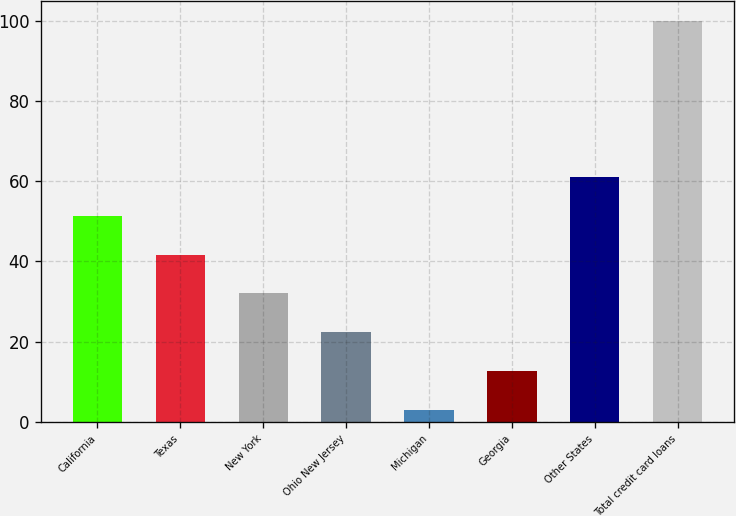Convert chart. <chart><loc_0><loc_0><loc_500><loc_500><bar_chart><fcel>California<fcel>Texas<fcel>New York<fcel>Ohio New Jersey<fcel>Michigan<fcel>Georgia<fcel>Other States<fcel>Total credit card loans<nl><fcel>51.45<fcel>41.74<fcel>32.03<fcel>22.32<fcel>2.9<fcel>12.61<fcel>61.16<fcel>100<nl></chart> 